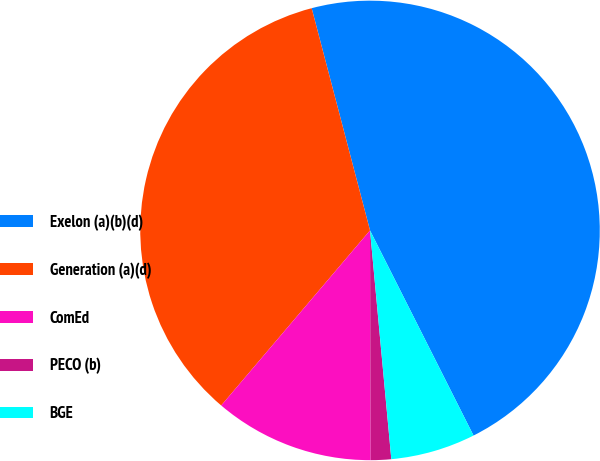Convert chart. <chart><loc_0><loc_0><loc_500><loc_500><pie_chart><fcel>Exelon (a)(b)(d)<fcel>Generation (a)(d)<fcel>ComEd<fcel>PECO (b)<fcel>BGE<nl><fcel>46.65%<fcel>34.7%<fcel>11.25%<fcel>1.44%<fcel>5.96%<nl></chart> 